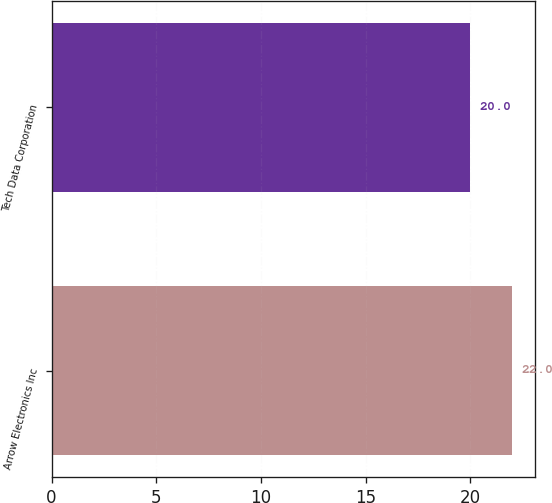Convert chart to OTSL. <chart><loc_0><loc_0><loc_500><loc_500><bar_chart><fcel>Arrow Electronics Inc<fcel>Tech Data Corporation<nl><fcel>22<fcel>20<nl></chart> 